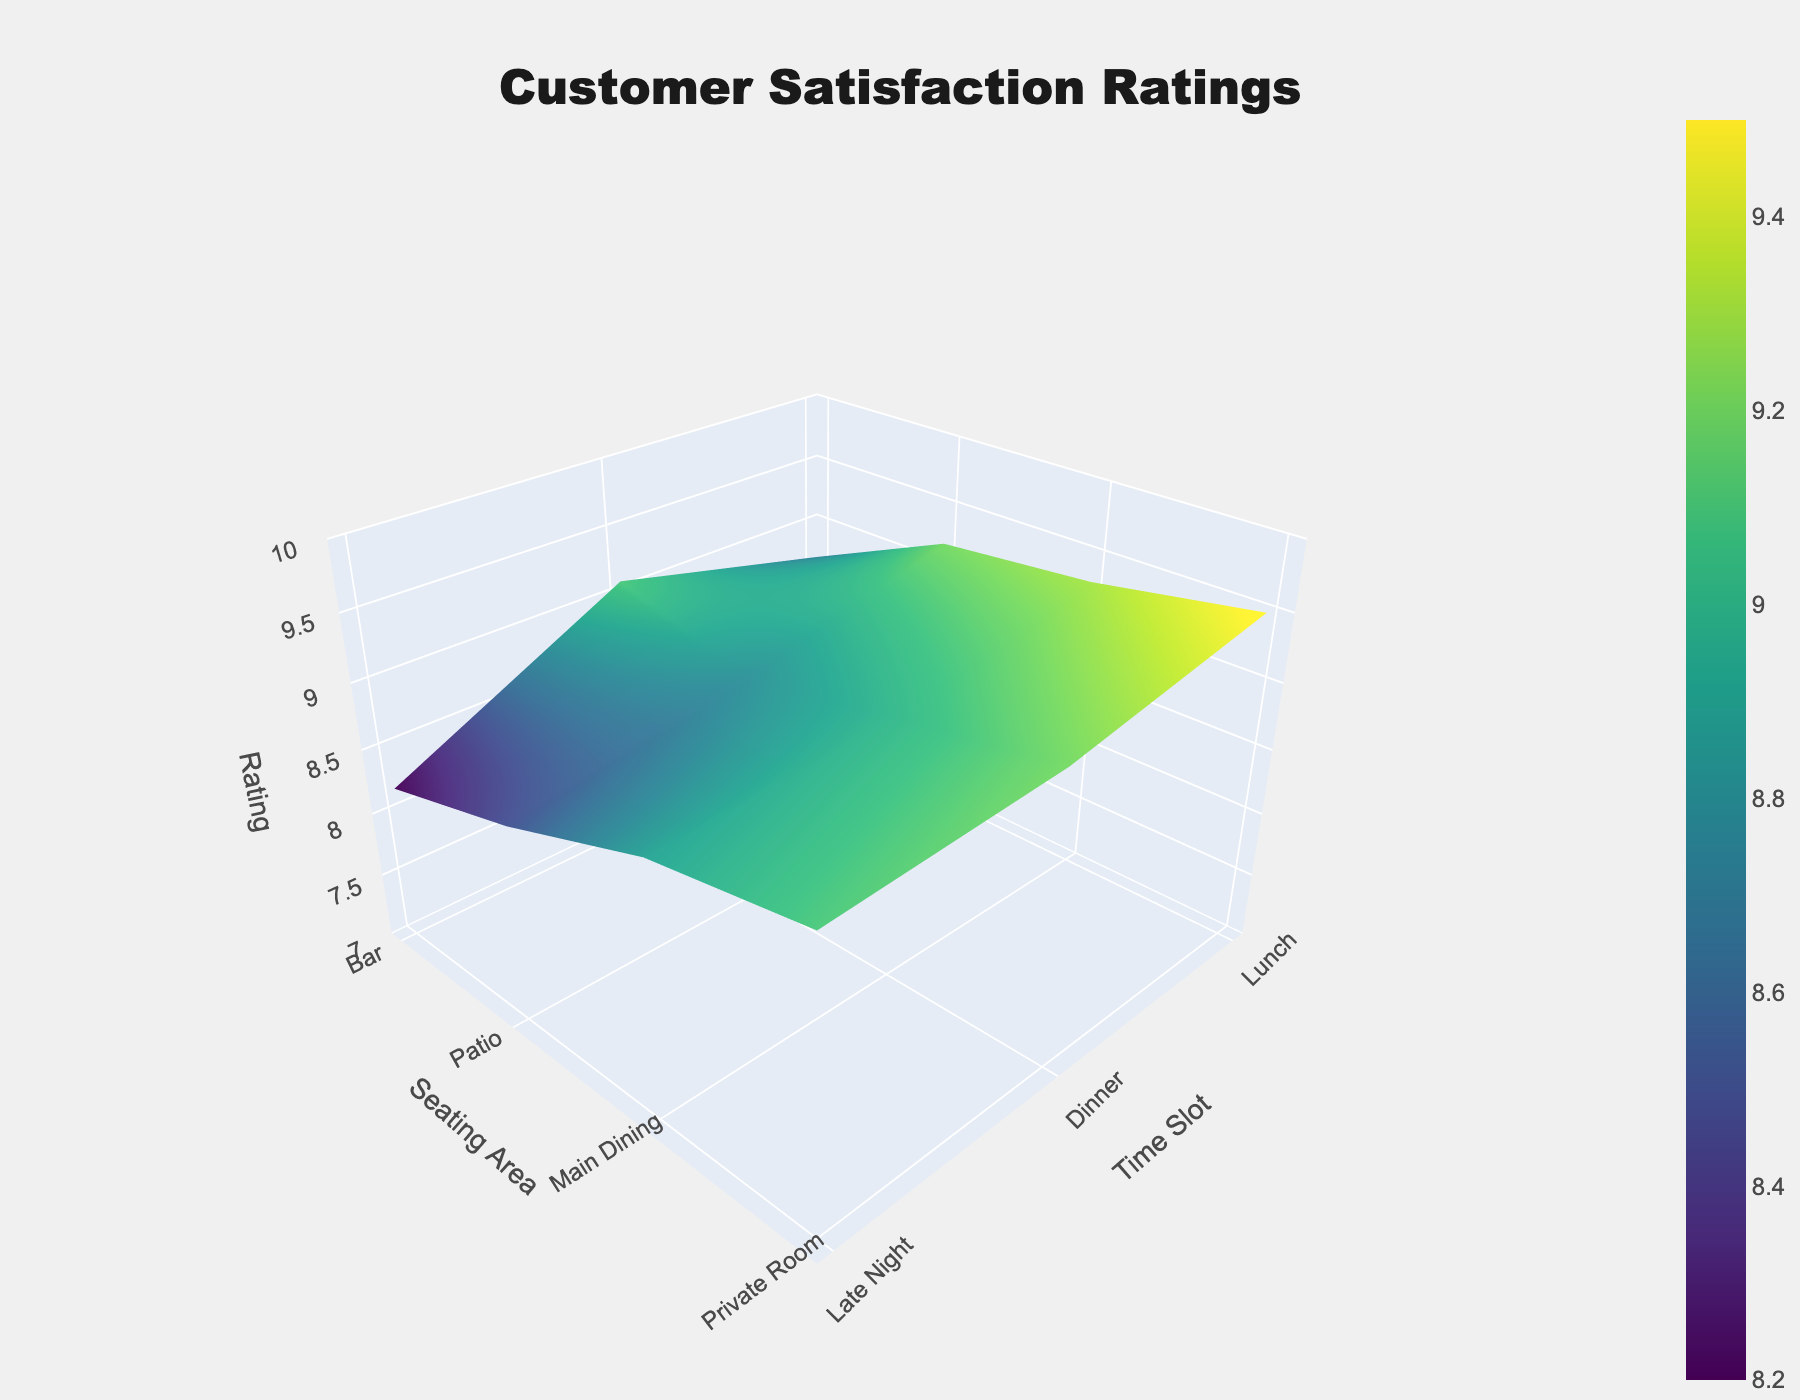What is the title of the figure? The title of the figure is usually displayed at the top, and in this case, it is clearly stated in the layout.
Answer: Customer Satisfaction Ratings Which category has the highest ratings for ambiance in the Private Room during dinner time? To find this, locate the surface plot named 'Ambiance'. Within this plot, find the section for the Private Room during dinner time and observe the z-axis value.
Answer: 9.5 How do the service ratings in the Main Dining area at dinner compare to those in the Bar at lunch? First, identify the ratings from the 'Service' plot for both time slots and locations. Main Dining during dinner is 9.0, and Bar during lunch is 7.9. The comparison shows that service is higher in Main Dining at dinner.
Answer: Main Dining at dinner is higher What is the average food quality rating across all seating areas at lunch time? To compute the average food quality at lunch, take the Food Quality ratings for lunch from the Bar (8.5), Patio (8.7), Main Dining (9.1), and Private Room (9.2). Summing these gives 35.5; dividing by the number of areas (4) results in the average.
Answer: 8.875 Which time slot generally has the highest overall customer satisfaction ratings across all seating areas? Analyze the ratings across all categories (Ambiance, Service, Food Quality) in the plots. Observing the z-values at different time slots for all seating areas, dinner time tends to have higher ratings in all categories.
Answer: Dinner How do ambiance ratings change from lunch to late night in the Patio seating area? For the Patio area, check the 'Ambiance' plot values at lunch (8.9) and late night (9.0). The change can be observed as a slight increase from 8.9 to 9.0.
Answer: Increases slightly What is the difference in food quality ratings between the highest and lowest rated seating areas across all time slots? Identify the highest and lowest ratings in the 'Food Quality' plot. The highest is in Private Room during dinner (9.5) and the lowest in Bar late night (8.4). The difference is calculated as 9.5 - 8.4.
Answer: 1.1 Between ambiance, service, and food quality, which category shows the most consistent ratings across different seating areas and time slots? Compare the variability in z-values across different plots. Ambiance ratings show a smaller range of differences across various seating areas and time slots, indicating more consistency.
Answer: Ambiance 